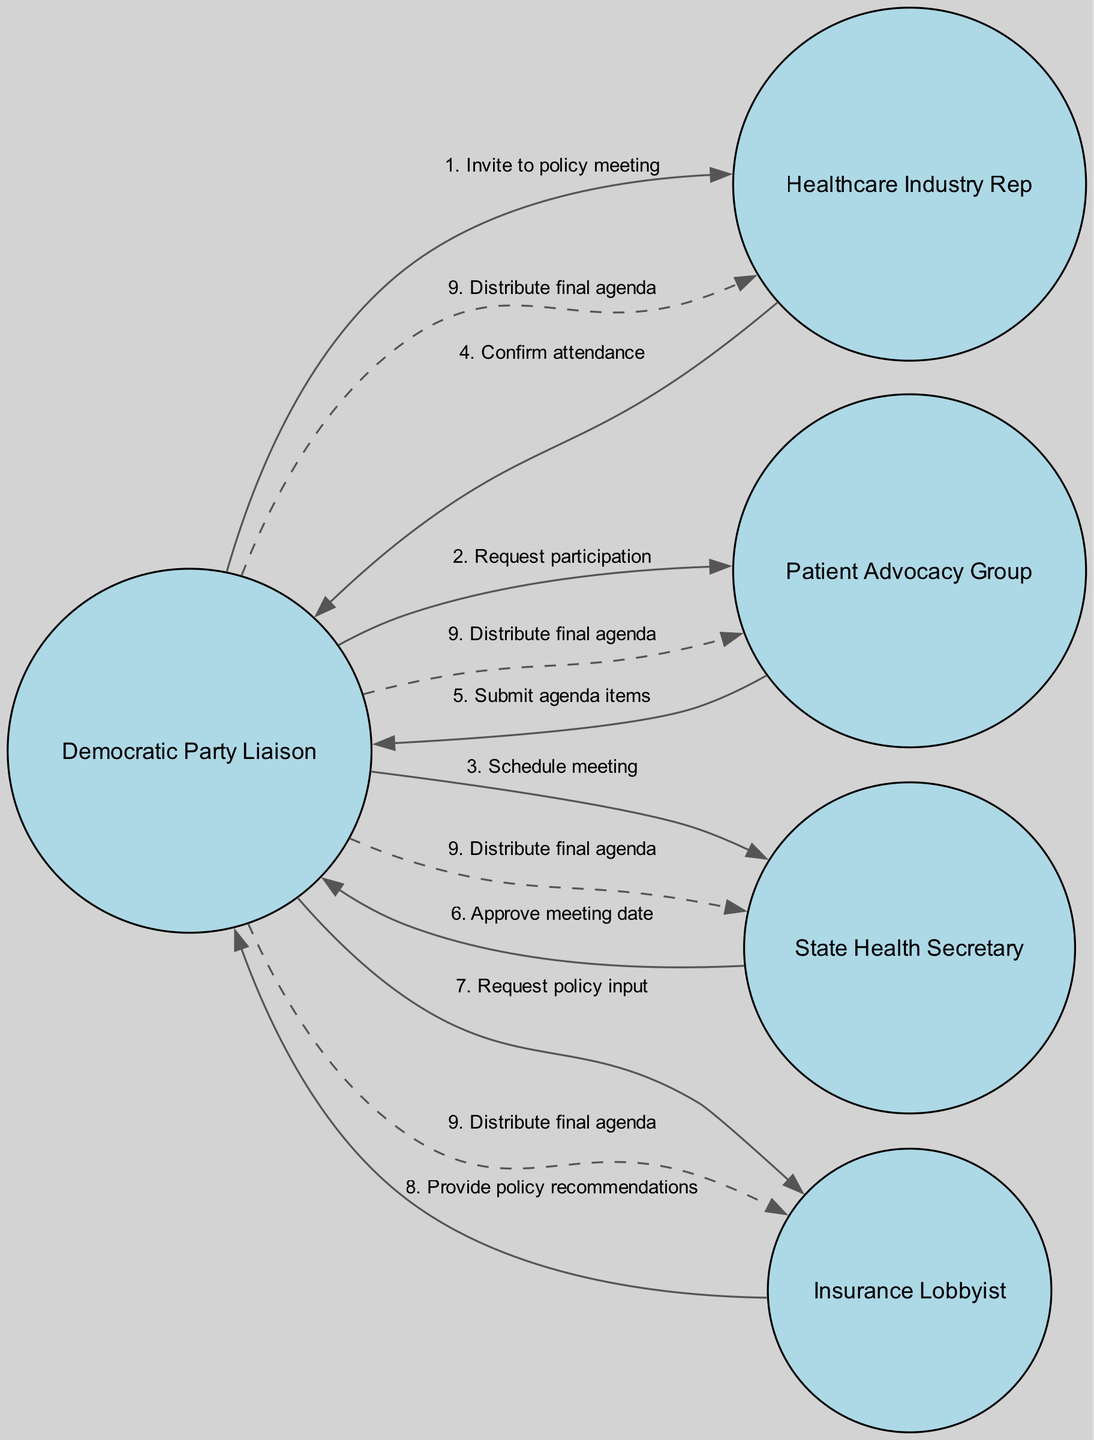What are the five actors involved in this sequence diagram? The actors are listed in the diagram as nodes, which include: Democratic Party Liaison, Healthcare Industry Rep, Patient Advocacy Group, State Health Secretary, and Insurance Lobbyist. These can be counted directly from the diagram.
Answer: Five Who does the Democratic Party Liaison invite to the policy meeting? The diagram shows that the Democratic Party Liaison sends an invitation specifically to the Healthcare Industry Representative. This can be identified by focusing on the first interaction in the sequence.
Answer: Healthcare Industry Rep How many edges are there between the Democratic Party Liaison and the Healthcare Industry Rep? The diagram includes a single edge showing the invitation from the Democratic Party Liaison to the Healthcare Industry Rep, which is the only connection between these two actors, as represented in the interactions.
Answer: One What is the third message sent in the sequence? By examining the order of interactions in the sequence, the third message is "Schedule meeting" which is sent from the Democratic Party Liaison to the State Health Secretary. This can be verified by counting the sequence.
Answer: Schedule meeting Which actor submits agenda items? According to the sequence, the Patient Advocacy Group is responsible for submitting agenda items to the Democratic Party Liaison. This is detailed in one of the interactions.
Answer: Patient Advocacy Group Who provides policy recommendations in the sequence? The edge from the Insurance Lobbyist to the Democratic Party Liaison indicates that the Insurance Lobbyist is the actor who provides policy recommendations. This can be verified by tracing the associated interaction in the diagram.
Answer: Insurance Lobbyist How many total messages are exchanged in the sequence? By counting each message listed in the interactions from the sequence, there are a total of eight distinct messages exchanged among the actors. This requires tallying up each unique interaction presented in the diagram.
Answer: Eight What action does the State Health Secretary take after being contacted by the Democratic Party Liaison? The third interaction indicates that the State Health Secretary approves the meeting date after being contacted by the Democratic Party Liaison, which can be clearly seen in the sequence.
Answer: Approve meeting date What does the Democratic Party Liaison do at the end of the sequence? At the end of the sequence, the Democratic Party Liaison is shown to distribute the final agenda to all participating actors, which is the last action in the sequence diagram.
Answer: Distribute final agenda 